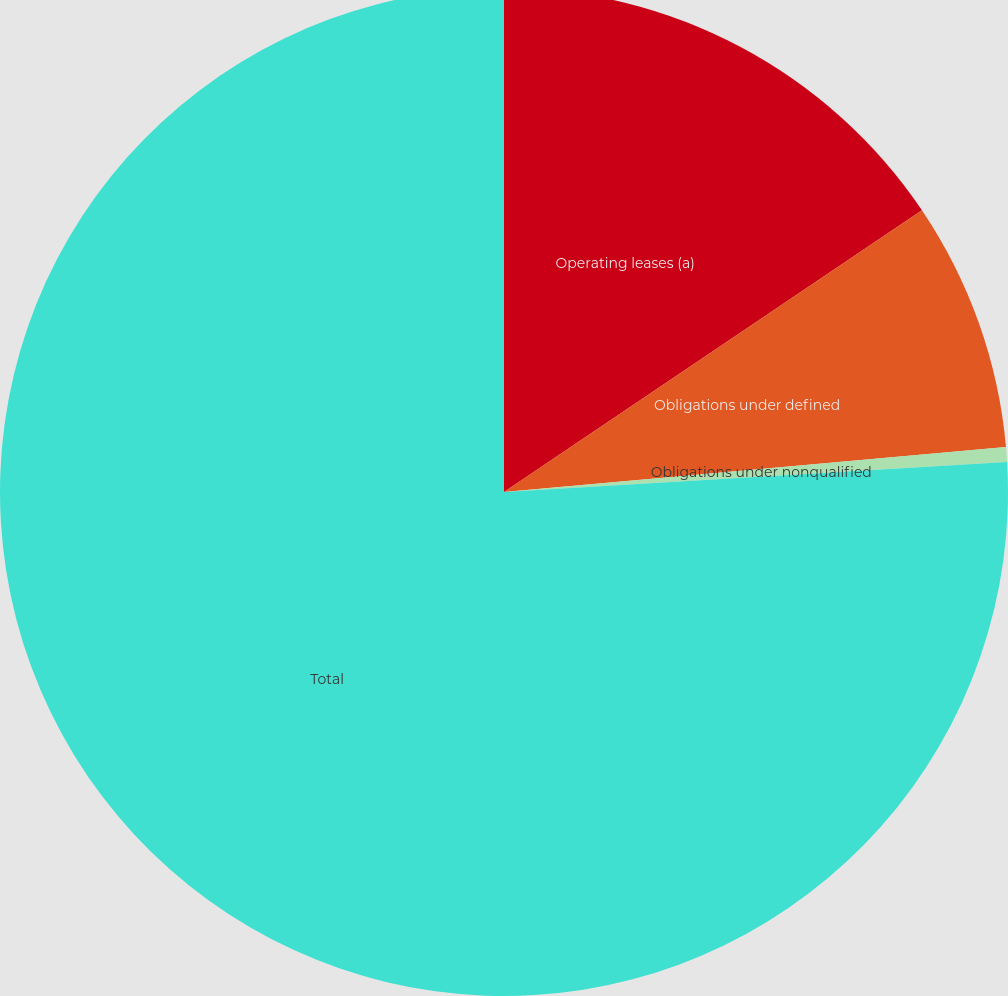Convert chart to OTSL. <chart><loc_0><loc_0><loc_500><loc_500><pie_chart><fcel>Operating leases (a)<fcel>Obligations under defined<fcel>Obligations under nonqualified<fcel>Total<nl><fcel>15.56%<fcel>8.02%<fcel>0.47%<fcel>75.95%<nl></chart> 